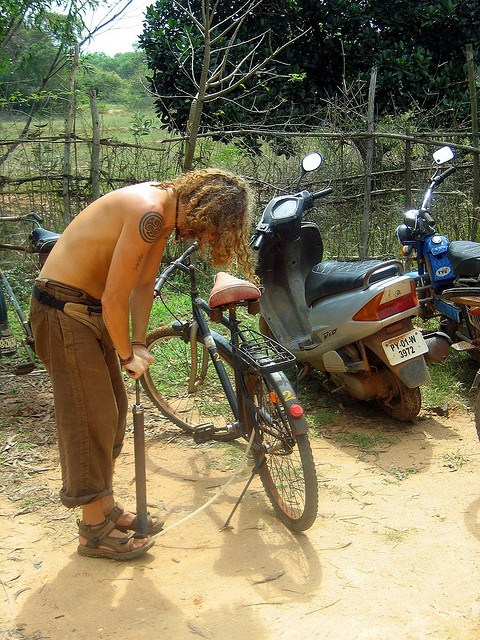Please extract the text content from this image. PY&#5867;01&#5867;W 3972 3972 2 2 